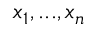Convert formula to latex. <formula><loc_0><loc_0><loc_500><loc_500>x _ { 1 } , \dots , x _ { n }</formula> 